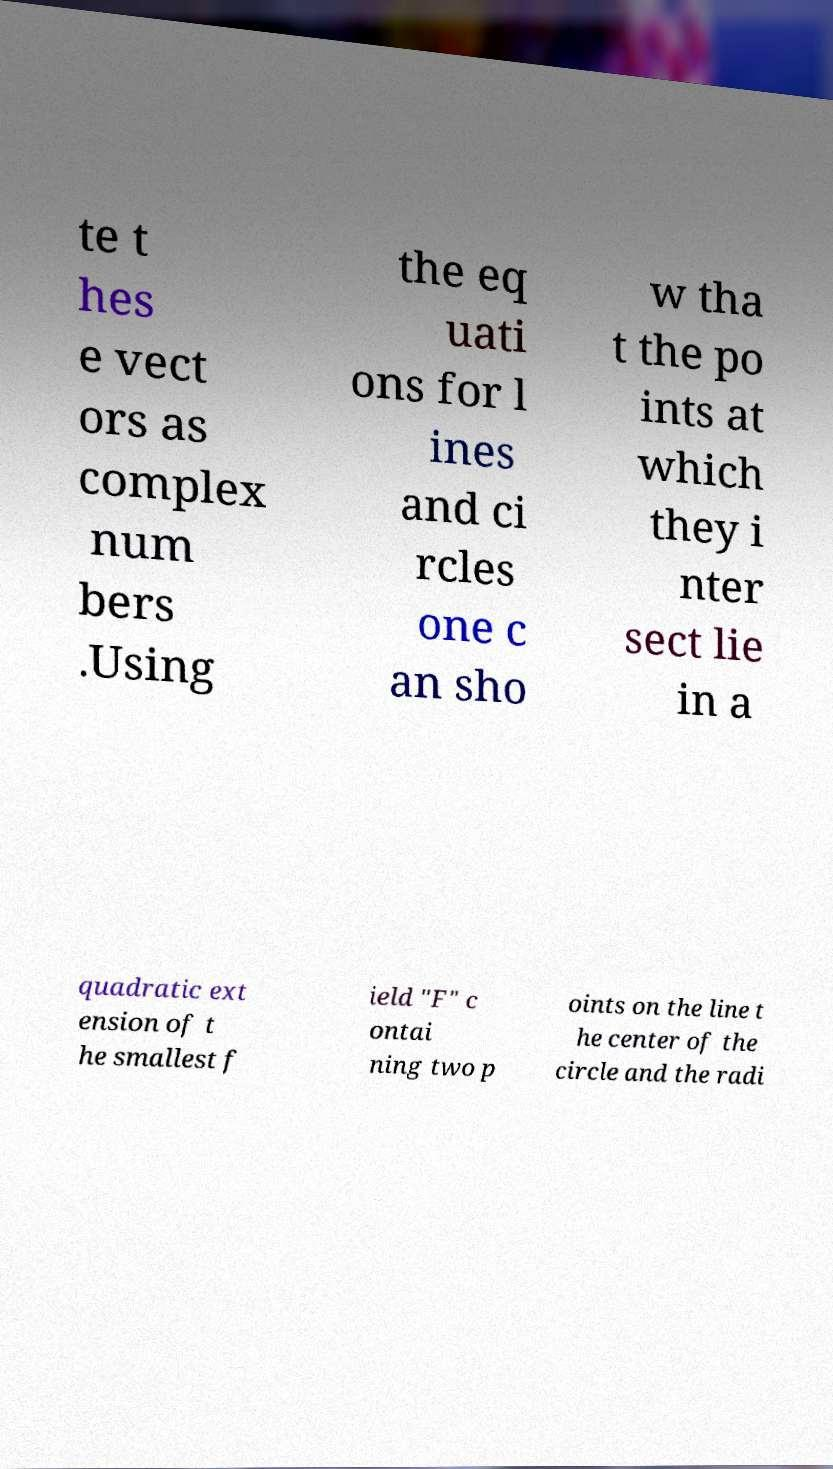Please read and relay the text visible in this image. What does it say? te t hes e vect ors as complex num bers .Using the eq uati ons for l ines and ci rcles one c an sho w tha t the po ints at which they i nter sect lie in a quadratic ext ension of t he smallest f ield "F" c ontai ning two p oints on the line t he center of the circle and the radi 